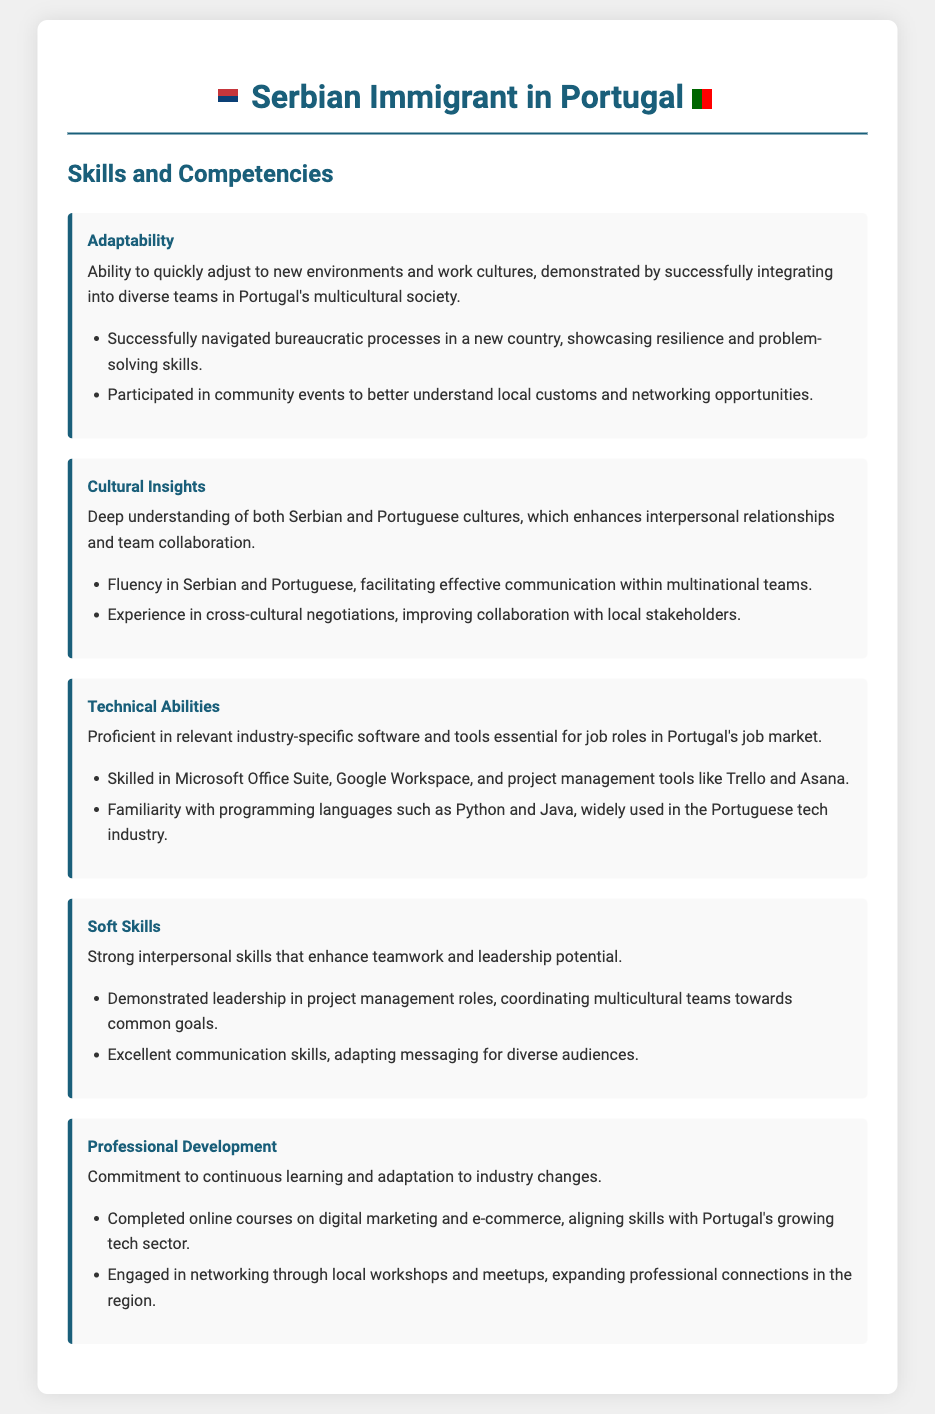What is the skill related to adjusting to new environments? The document indicates "Adaptability" as the skill related to adjusting to new environments.
Answer: Adaptability How many languages is the individual fluent in? The section on cultural insights states that the individual is fluent in Serbian and Portuguese.
Answer: Two What tool is mentioned for project management? The technical abilities section lists "Trello" and "Asana" as project management tools.
Answer: Trello and Asana What is emphasized in the "Professional Development" section? This section highlights a commitment to continuous learning and adaptation to industry changes.
Answer: Continuous learning What type of skills enhance teamwork according to the resume? The resume mentions "Soft Skills" as the type of skills that enhance teamwork.
Answer: Soft Skills What cultural aspects are highlighted in the document? The document highlights having deep understanding of both Serbian and Portuguese cultures.
Answer: Serbian and Portuguese cultures Which programming language is mentioned as familiar in the document? The technical abilities section states familiarity with "Python" and "Java."
Answer: Python and Java In what context did the individual engage with the local culture? The adaptability section mentions participation in community events to better understand local customs.
Answer: Community events 